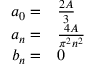<formula> <loc_0><loc_0><loc_500><loc_500>\begin{array} { r l } { a _ { 0 } = } & { \frac { 2 A } { 3 } } } \\ { a _ { n } = } & { \frac { 4 A } { \pi ^ { 2 } n ^ { 2 } } } } \\ { b _ { n } = } & 0 } \end{array}</formula> 